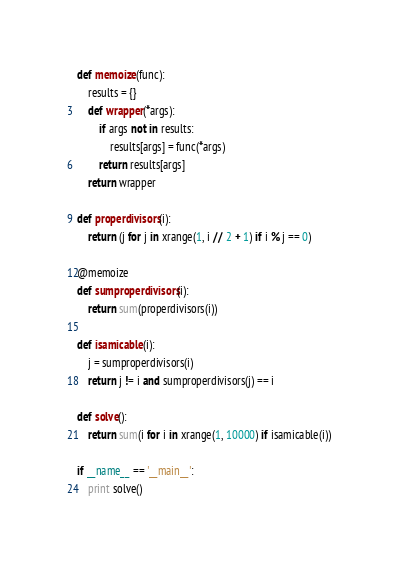<code> <loc_0><loc_0><loc_500><loc_500><_Python_>def memoize(func):
    results = {}
    def wrapper(*args):
        if args not in results:
            results[args] = func(*args)
        return results[args]
    return wrapper

def properdivisors(i):
    return (j for j in xrange(1, i // 2 + 1) if i % j == 0)

@memoize
def sumproperdivisors(i):
    return sum(properdivisors(i))

def isamicable(i):
    j = sumproperdivisors(i)
    return j != i and sumproperdivisors(j) == i
    
def solve():
    return sum(i for i in xrange(1, 10000) if isamicable(i))

if __name__ == '__main__':
    print solve()
</code> 